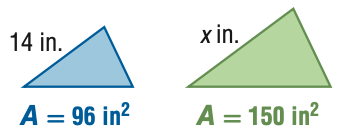Question: For the pair of similar figures, use the given areas to find the scale factor of the blue to the green figure.
Choices:
A. \frac { 16 } { 25 }
B. \frac { 4 } { 5 }
C. \frac { 5 } { 4 }
D. \frac { 25 } { 16 }
Answer with the letter. Answer: B 